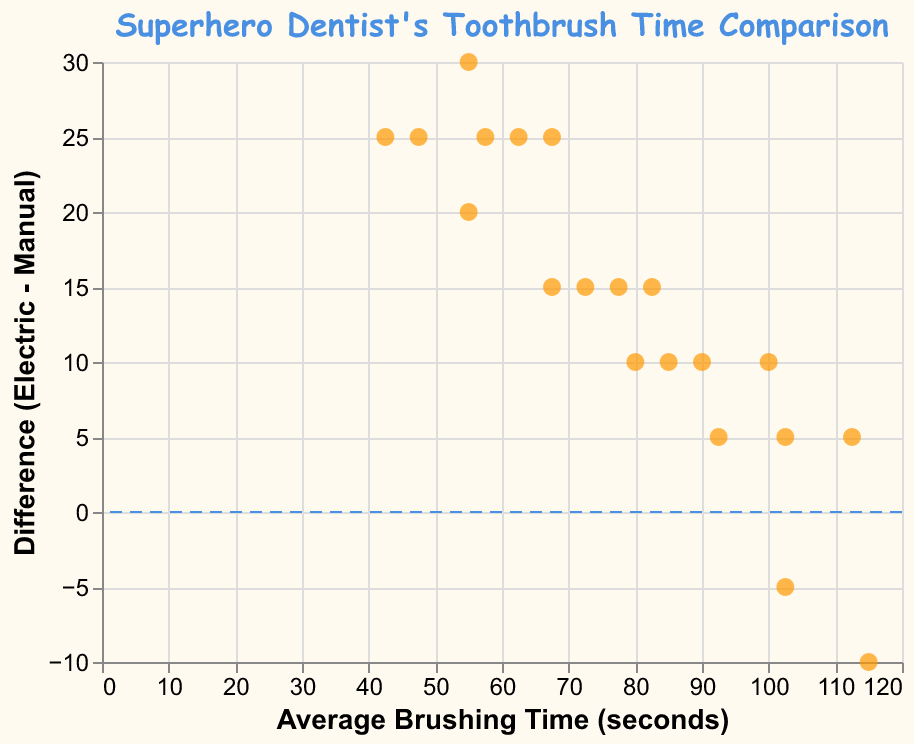How many data points are used in the plot? Count the number of orange dots (points) in the plot.
Answer: 20 What is the title of the figure? The title is displayed at the top of the figure in blue color.
Answer: Superhero Dentist's Toothbrush Time Comparison What is the range of the x-axis? Look at the lowest and highest values on the x-axis, labelled as Average Brushing Time (seconds).
Answer: 30 to 115 What color are the points in the plot? Observe the filled color of the points in the plot.
Answer: Orange What does the y-axis represent? Check the label on the y-axis on the left side of the figure.
Answer: Difference (Electric - Manual) What does the horizontal dashed rule at y = 0 indicate? The horizontal dashed rule at y = 0 represents no difference between manual and electric brushing times. Points above this line show a positive difference (electric longer), and points below show a negative difference (manual longer).
Answer: No difference between brushing times What is the average brushing time when the difference is the largest? Identify the point with the largest difference on the y-axis, then check its x-axis value (average time). The largest positive difference is higher on the plot.
Answer: (30 + 55)/2 = 42.5 Between which values is the majority of average brushing times located? Observe the concentration of points along the x-axis to see where most points fall.
Answer: Between 40 and 100 seconds Is there more variation in brushing times for manual or electric toothbrushes? Check the spread of points along the y-axis, differences show variation levels between the two types of toothbrushes.
Answer: More variation for electric toothbrushes 